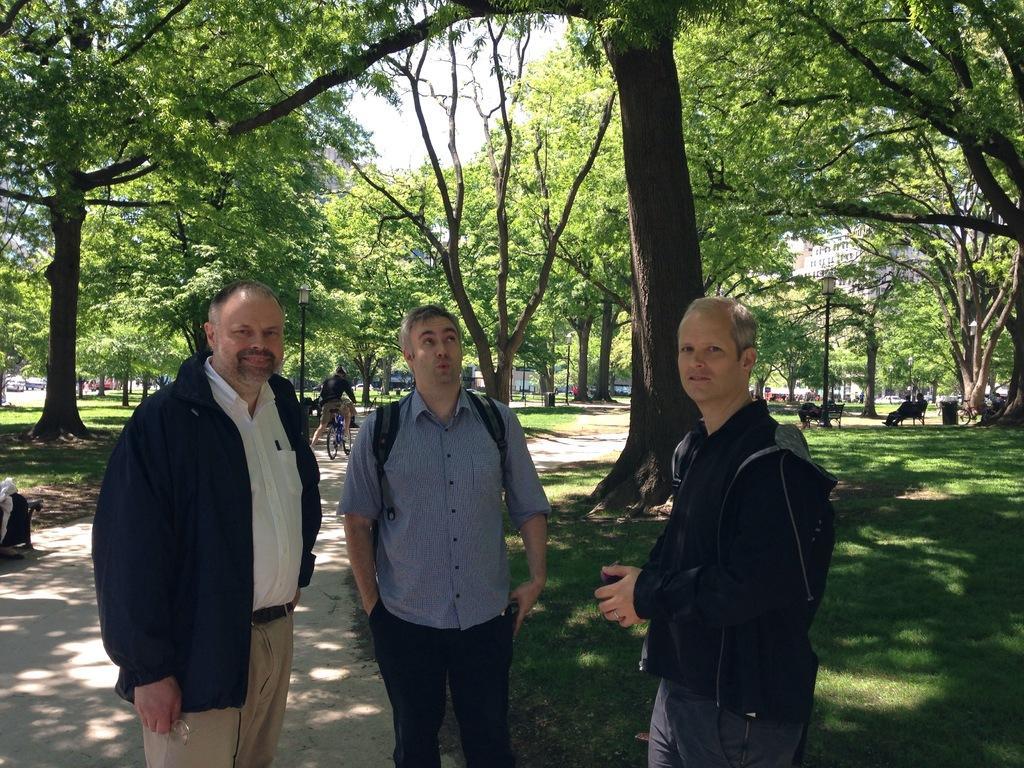In one or two sentences, can you explain what this image depicts? In this picture there are men in the center of the image and there is grassland on the right and left side of the image, there are buildings and trees in the background area of the image and there is a boy who is cycling on the left side of the image. 